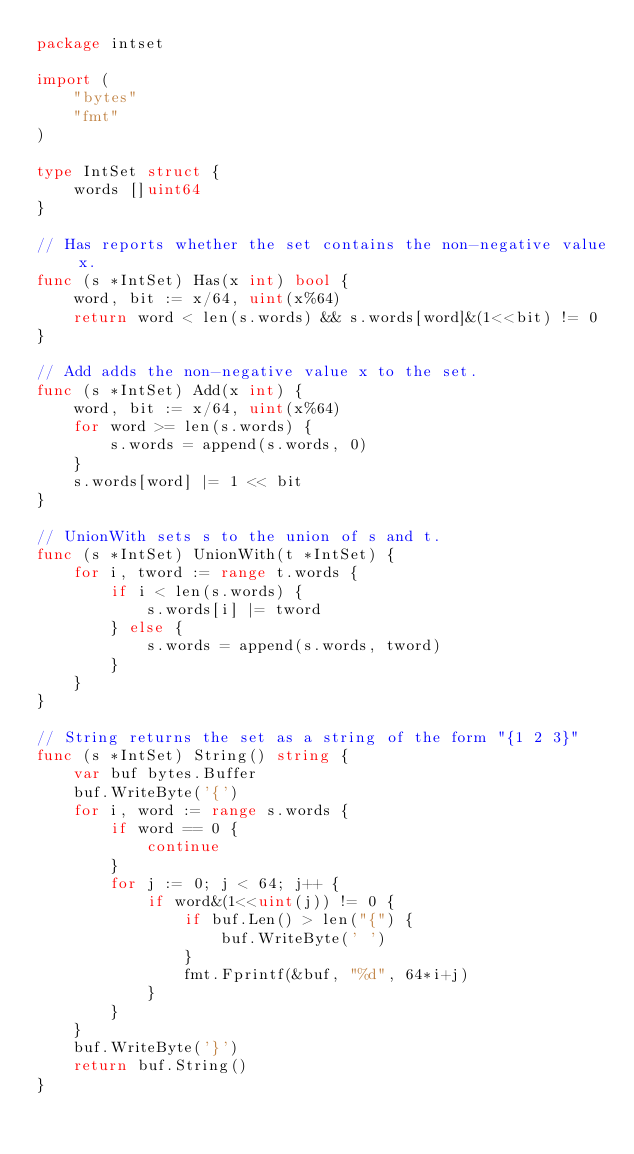<code> <loc_0><loc_0><loc_500><loc_500><_Go_>package intset

import (
	"bytes"
	"fmt"
)

type IntSet struct {
	words []uint64
}

// Has reports whether the set contains the non-negative value x.
func (s *IntSet) Has(x int) bool {
	word, bit := x/64, uint(x%64)
	return word < len(s.words) && s.words[word]&(1<<bit) != 0
}

// Add adds the non-negative value x to the set.
func (s *IntSet) Add(x int) {
	word, bit := x/64, uint(x%64)
	for word >= len(s.words) {
		s.words = append(s.words, 0)
	}
	s.words[word] |= 1 << bit
}

// UnionWith sets s to the union of s and t.
func (s *IntSet) UnionWith(t *IntSet) {
	for i, tword := range t.words {
		if i < len(s.words) {
			s.words[i] |= tword
		} else {
			s.words = append(s.words, tword)
		}
	}
}

// String returns the set as a string of the form "{1 2 3}"
func (s *IntSet) String() string {
	var buf bytes.Buffer
	buf.WriteByte('{')
	for i, word := range s.words {
		if word == 0 {
			continue
		}
		for j := 0; j < 64; j++ {
			if word&(1<<uint(j)) != 0 {
				if buf.Len() > len("{") {
					buf.WriteByte(' ')
				}
				fmt.Fprintf(&buf, "%d", 64*i+j)
			}
		}
	}
	buf.WriteByte('}')
	return buf.String()
}
</code> 